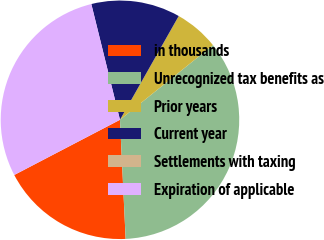<chart> <loc_0><loc_0><loc_500><loc_500><pie_chart><fcel>in thousands<fcel>Unrecognized tax benefits as<fcel>Prior years<fcel>Current year<fcel>Settlements with taxing<fcel>Expiration of applicable<nl><fcel>18.1%<fcel>35.01%<fcel>6.03%<fcel>12.06%<fcel>0.0%<fcel>28.79%<nl></chart> 